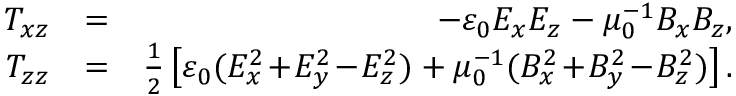Convert formula to latex. <formula><loc_0><loc_0><loc_500><loc_500>\begin{array} { r l r } { T _ { x z } } & { = } & { - \varepsilon _ { 0 } E _ { x } E _ { z } - \mu _ { 0 } ^ { - 1 } B _ { x } B _ { z } , } \\ { T _ { z z } } & { = } & { \frac { 1 } { 2 } \left [ \varepsilon _ { 0 } ( E _ { x } ^ { 2 } \, + \, E _ { y } ^ { 2 } \, - \, E _ { z } ^ { 2 } ) + \mu _ { 0 } ^ { - 1 } ( B _ { x } ^ { 2 } \, + \, B _ { y } ^ { 2 } \, - \, B _ { z } ^ { 2 } ) \right ] . } \end{array}</formula> 